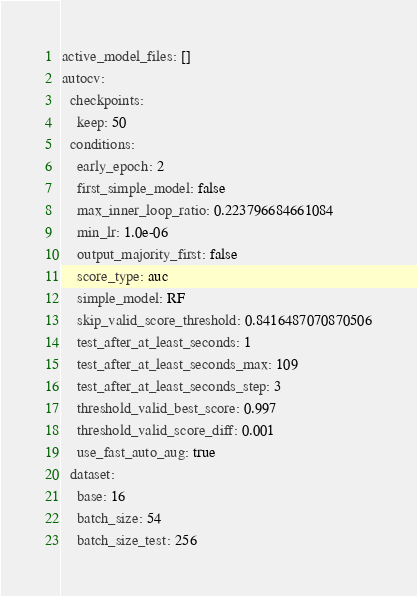Convert code to text. <code><loc_0><loc_0><loc_500><loc_500><_YAML_>active_model_files: []
autocv:
  checkpoints:
    keep: 50
  conditions:
    early_epoch: 2
    first_simple_model: false
    max_inner_loop_ratio: 0.223796684661084
    min_lr: 1.0e-06
    output_majority_first: false
    score_type: auc
    simple_model: RF
    skip_valid_score_threshold: 0.8416487070870506
    test_after_at_least_seconds: 1
    test_after_at_least_seconds_max: 109
    test_after_at_least_seconds_step: 3
    threshold_valid_best_score: 0.997
    threshold_valid_score_diff: 0.001
    use_fast_auto_aug: true
  dataset:
    base: 16
    batch_size: 54
    batch_size_test: 256</code> 